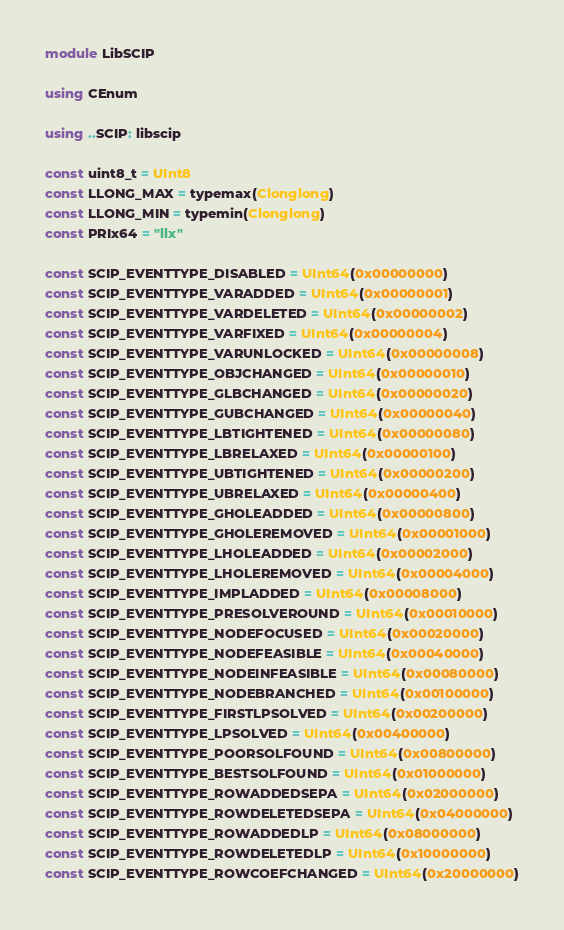Convert code to text. <code><loc_0><loc_0><loc_500><loc_500><_Julia_>module LibSCIP

using CEnum

using ..SCIP: libscip

const uint8_t = UInt8
const LLONG_MAX = typemax(Clonglong)
const LLONG_MIN = typemin(Clonglong)
const PRIx64 = "llx"

const SCIP_EVENTTYPE_DISABLED = UInt64(0x00000000)
const SCIP_EVENTTYPE_VARADDED = UInt64(0x00000001)
const SCIP_EVENTTYPE_VARDELETED = UInt64(0x00000002)
const SCIP_EVENTTYPE_VARFIXED = UInt64(0x00000004)
const SCIP_EVENTTYPE_VARUNLOCKED = UInt64(0x00000008)
const SCIP_EVENTTYPE_OBJCHANGED = UInt64(0x00000010)
const SCIP_EVENTTYPE_GLBCHANGED = UInt64(0x00000020)
const SCIP_EVENTTYPE_GUBCHANGED = UInt64(0x00000040)
const SCIP_EVENTTYPE_LBTIGHTENED = UInt64(0x00000080)
const SCIP_EVENTTYPE_LBRELAXED = UInt64(0x00000100)
const SCIP_EVENTTYPE_UBTIGHTENED = UInt64(0x00000200)
const SCIP_EVENTTYPE_UBRELAXED = UInt64(0x00000400)
const SCIP_EVENTTYPE_GHOLEADDED = UInt64(0x00000800)
const SCIP_EVENTTYPE_GHOLEREMOVED = UInt64(0x00001000)
const SCIP_EVENTTYPE_LHOLEADDED = UInt64(0x00002000)
const SCIP_EVENTTYPE_LHOLEREMOVED = UInt64(0x00004000)
const SCIP_EVENTTYPE_IMPLADDED = UInt64(0x00008000)
const SCIP_EVENTTYPE_PRESOLVEROUND = UInt64(0x00010000)
const SCIP_EVENTTYPE_NODEFOCUSED = UInt64(0x00020000)
const SCIP_EVENTTYPE_NODEFEASIBLE = UInt64(0x00040000)
const SCIP_EVENTTYPE_NODEINFEASIBLE = UInt64(0x00080000)
const SCIP_EVENTTYPE_NODEBRANCHED = UInt64(0x00100000)
const SCIP_EVENTTYPE_FIRSTLPSOLVED = UInt64(0x00200000)
const SCIP_EVENTTYPE_LPSOLVED = UInt64(0x00400000)
const SCIP_EVENTTYPE_POORSOLFOUND = UInt64(0x00800000)
const SCIP_EVENTTYPE_BESTSOLFOUND = UInt64(0x01000000)
const SCIP_EVENTTYPE_ROWADDEDSEPA = UInt64(0x02000000)
const SCIP_EVENTTYPE_ROWDELETEDSEPA = UInt64(0x04000000)
const SCIP_EVENTTYPE_ROWADDEDLP = UInt64(0x08000000)
const SCIP_EVENTTYPE_ROWDELETEDLP = UInt64(0x10000000)
const SCIP_EVENTTYPE_ROWCOEFCHANGED = UInt64(0x20000000)</code> 